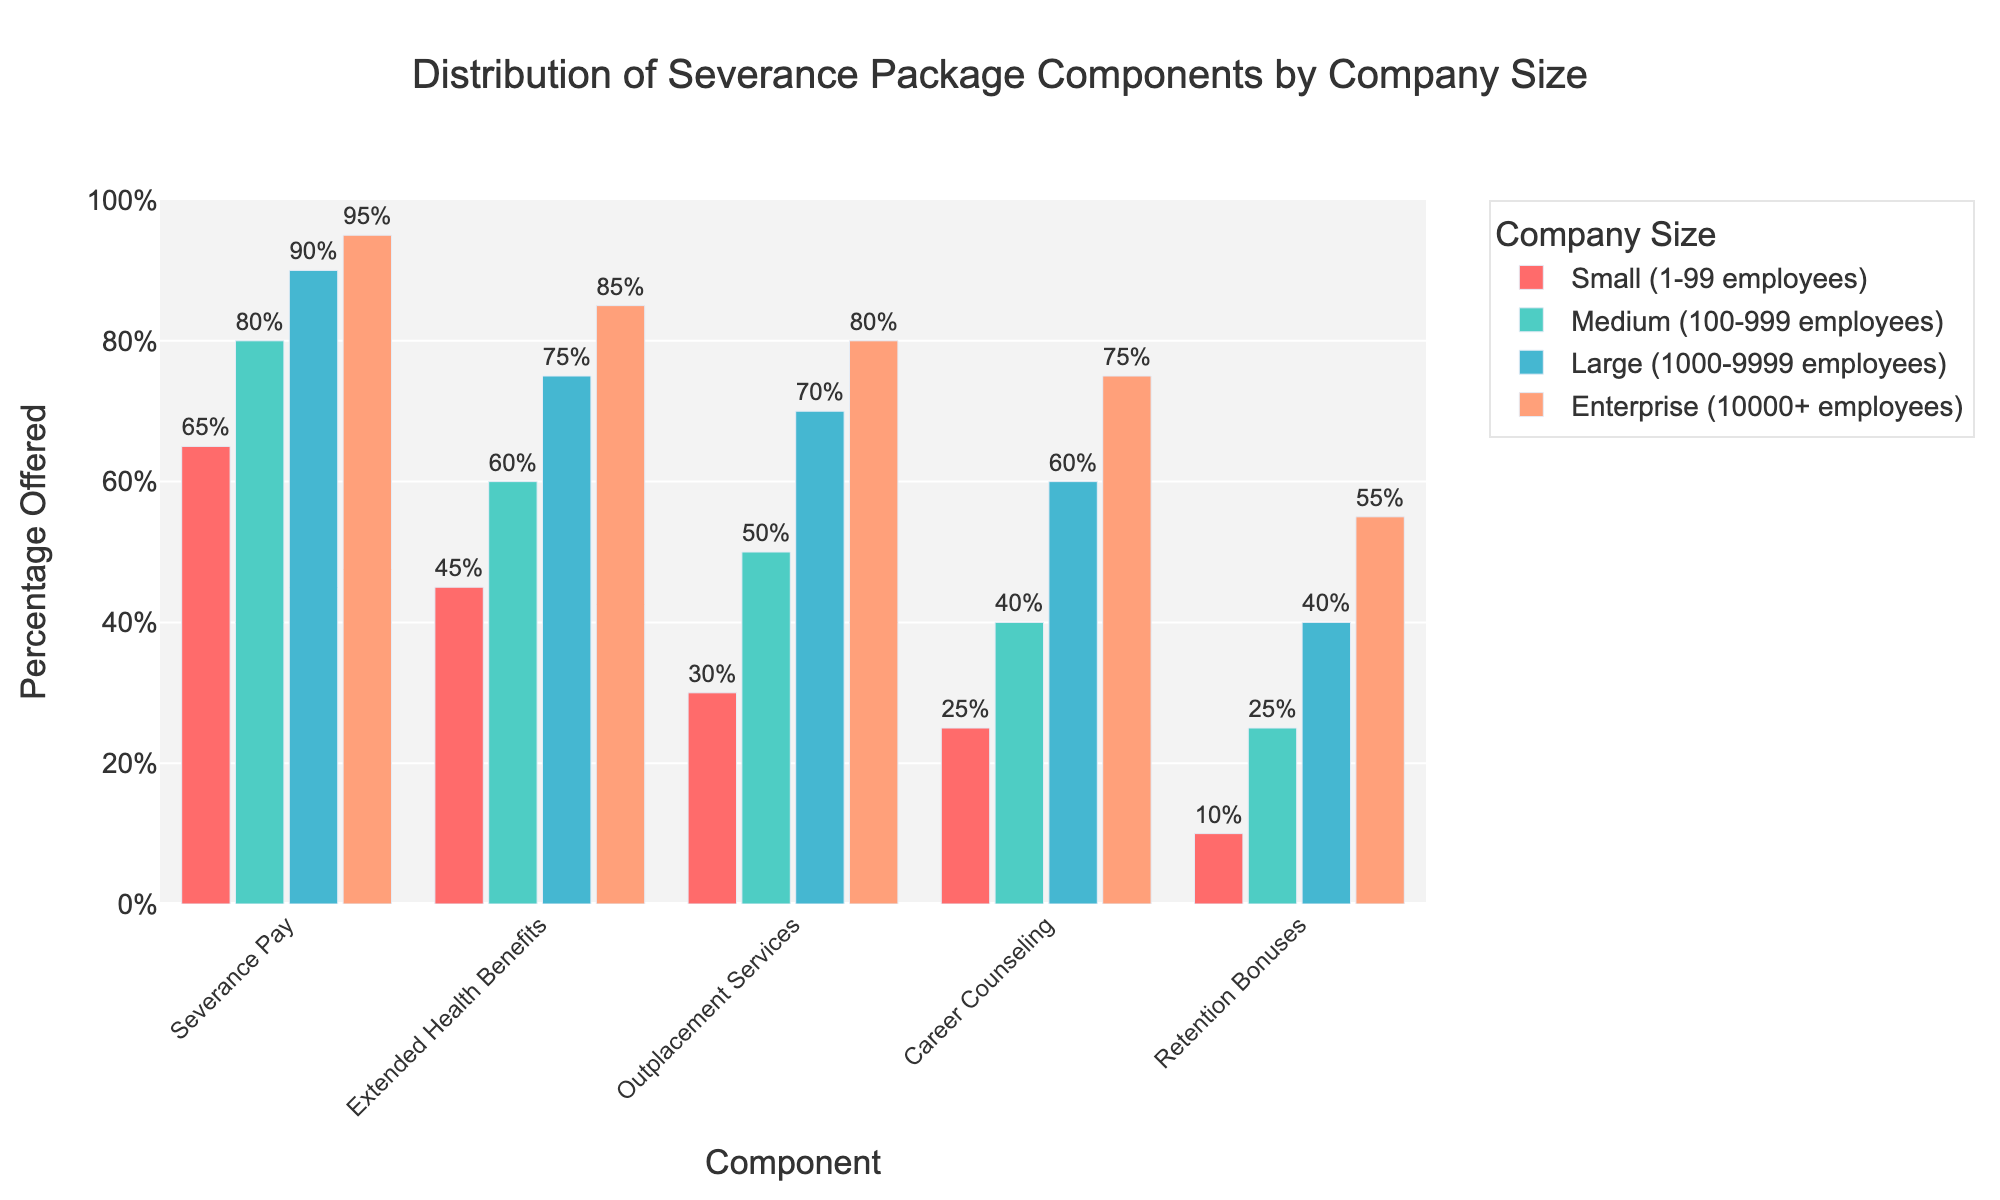What is the percentage of companies that offer both Severance Pay and Extended Health Benefits in Large companies? Large companies offer 90% Severance Pay and 75% Extended Health Benefits. Adding these together, 90 + 75 = 165% is the total percentage for these two components.
Answer: 165% Which company size offers the least percentage of Career Counseling? Looking at each bar for Career Counseling, the smallest bar is for Small companies, with 25%.
Answer: Small companies Between Medium and Large companies, which one offers a higher percentage of Outplacement Services and by how much? Medium companies offer 50% and Large companies offer 70% in Outplacement Services. The difference is 70 - 50 = 20%.
Answer: Large companies by 20% What is the difference in the percentage of Severance Pay offered by Small and Enterprise companies? Small companies offer 65% and Enterprise companies offer 95% for Severance Pay. The difference is 95 - 65 = 30%.
Answer: 30% Which benefit shows the greatest variance across all company sizes? Looking at the bar lengths for each benefit type across company sizes, Retention Bonuses vary the most, from 10% in Small to 55% in Enterprise, which is a range of 45%.
Answer: Retention Bonuses What is the combined percentage of Extended Health Benefits and Career Counseling offered by Medium companies? Medium companies offer 60% Extended Health Benefits and 40% Career Counseling. Combined, it is 60 + 40 = 100%.
Answer: 100% Which company size offers the highest percentage of Outplacement Services? The tallest bar for Outplacement Services is for Enterprise companies, at 80%.
Answer: Enterprise companies How much more does Enterprise offer in Retention Bonuses compared to Medium companies? Enterprise offers 55% in Retention Bonuses and Medium offers 25%. The difference is 55 - 25 = 30%.
Answer: 30% Is Severance Pay always the highest offered component in each company size? Looking at each set of bars, Severance Pay (red) is the tallest in all sizes: 65, 80, 90, and 95%.
Answer: Yes 